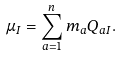<formula> <loc_0><loc_0><loc_500><loc_500>\mu _ { I } = \sum _ { a = 1 } ^ { n } m _ { a } Q _ { a I } .</formula> 